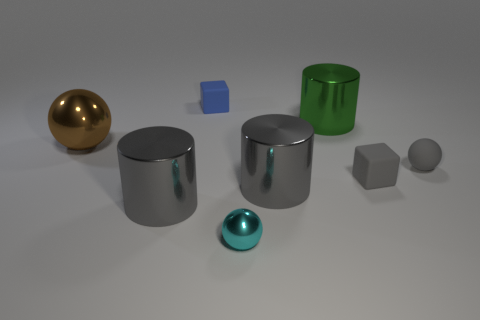Are there any brown shiny spheres to the left of the tiny blue matte thing?
Provide a succinct answer. Yes. The block that is the same color as the matte ball is what size?
Keep it short and to the point. Small. Is there a tiny gray thing made of the same material as the gray block?
Keep it short and to the point. Yes. The small metal ball is what color?
Keep it short and to the point. Cyan. There is a big brown metal thing in front of the green thing; does it have the same shape as the cyan metallic object?
Provide a succinct answer. Yes. What is the shape of the matte thing behind the small ball to the right of the tiny block in front of the green shiny cylinder?
Give a very brief answer. Cube. There is a large gray thing right of the small blue object; what material is it?
Give a very brief answer. Metal. There is another rubber sphere that is the same size as the cyan sphere; what is its color?
Ensure brevity in your answer.  Gray. How many other things are there of the same shape as the cyan thing?
Give a very brief answer. 2. Does the gray ball have the same size as the gray block?
Ensure brevity in your answer.  Yes. 